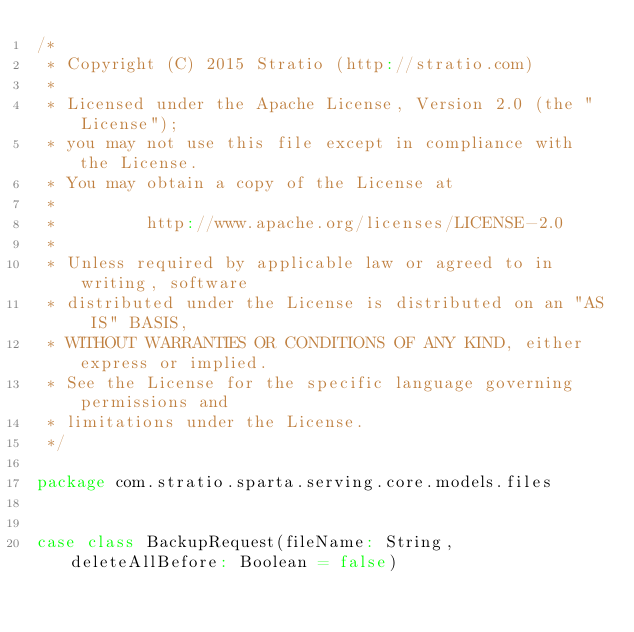<code> <loc_0><loc_0><loc_500><loc_500><_Scala_>/*
 * Copyright (C) 2015 Stratio (http://stratio.com)
 *
 * Licensed under the Apache License, Version 2.0 (the "License");
 * you may not use this file except in compliance with the License.
 * You may obtain a copy of the License at
 *
 *         http://www.apache.org/licenses/LICENSE-2.0
 *
 * Unless required by applicable law or agreed to in writing, software
 * distributed under the License is distributed on an "AS IS" BASIS,
 * WITHOUT WARRANTIES OR CONDITIONS OF ANY KIND, either express or implied.
 * See the License for the specific language governing permissions and
 * limitations under the License.
 */

package com.stratio.sparta.serving.core.models.files


case class BackupRequest(fileName: String, deleteAllBefore: Boolean = false)
</code> 